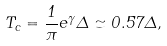Convert formula to latex. <formula><loc_0><loc_0><loc_500><loc_500>T _ { c } = { \frac { 1 } { \pi } } e ^ { \gamma } \Delta \simeq 0 . 5 7 \Delta ,</formula> 